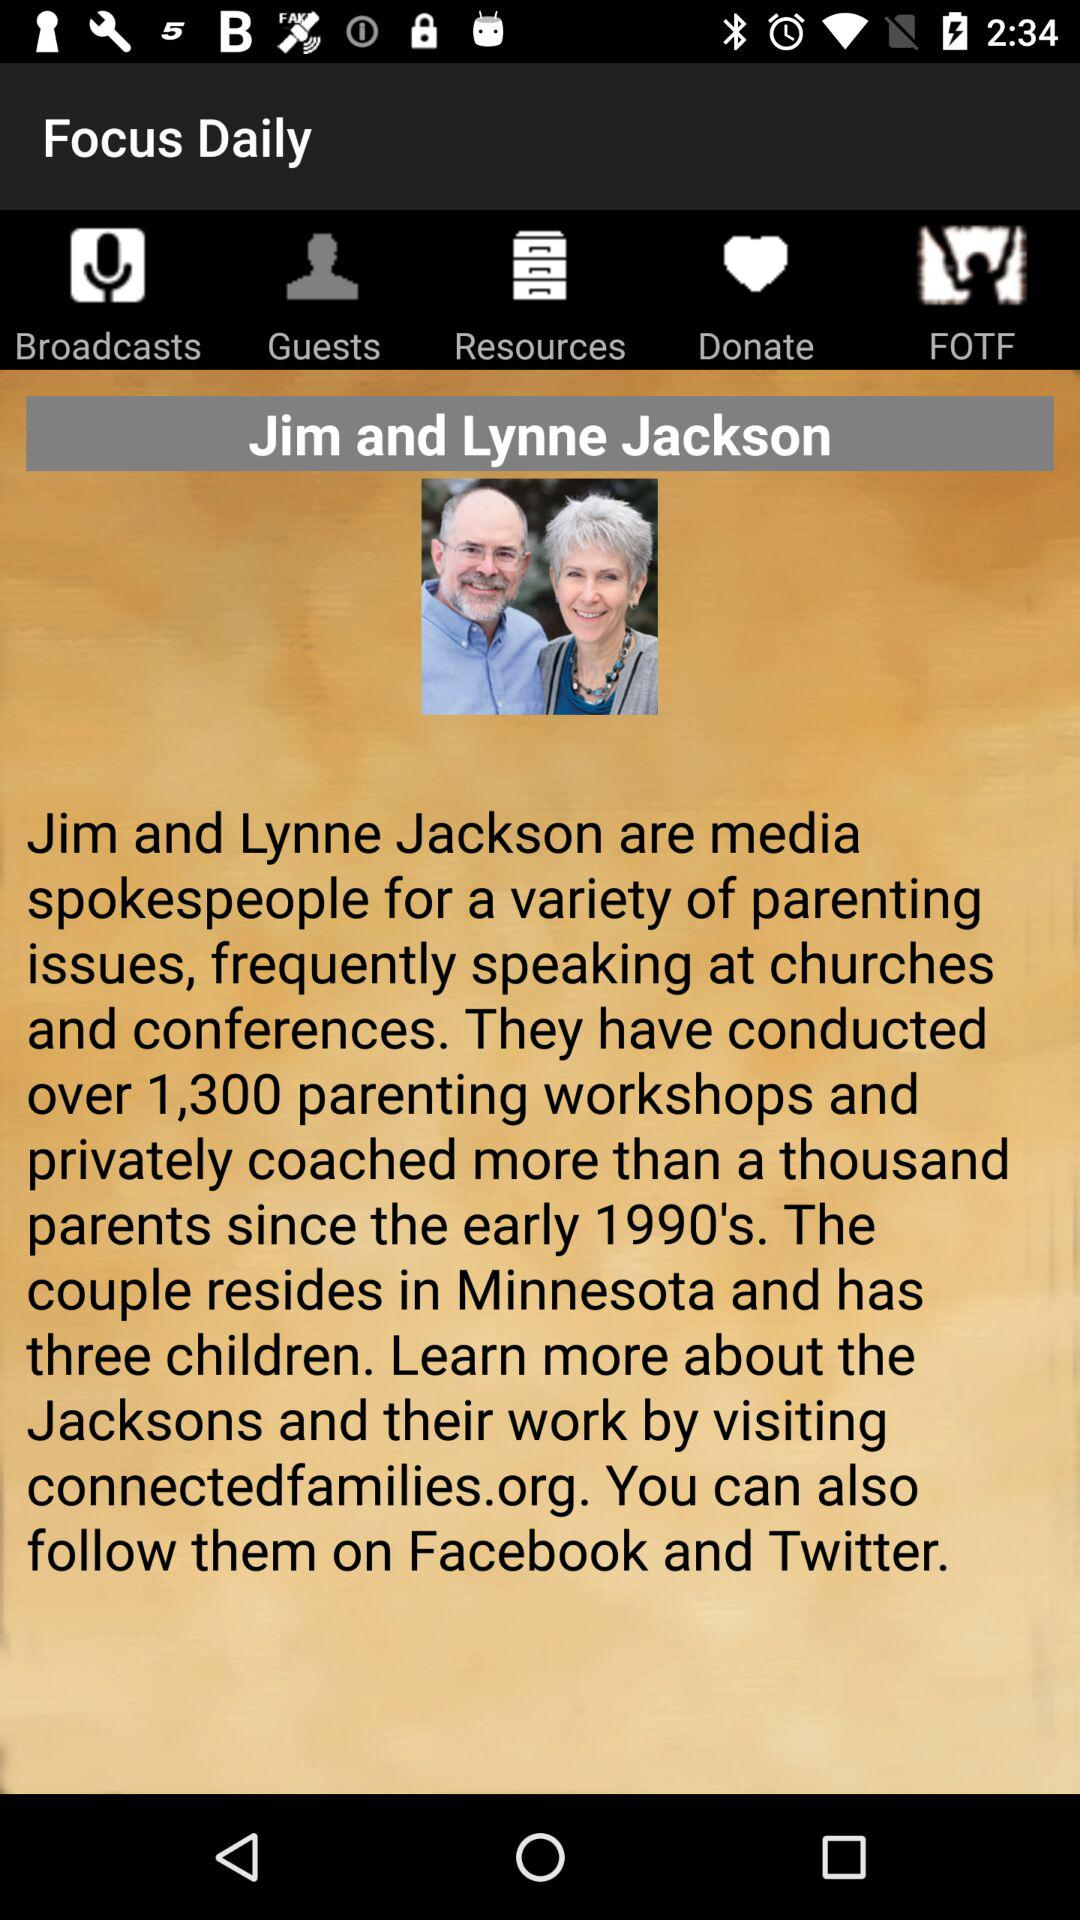Who are the media spokespeople? The media spokespeople are Jim and Lynne Jackson. 